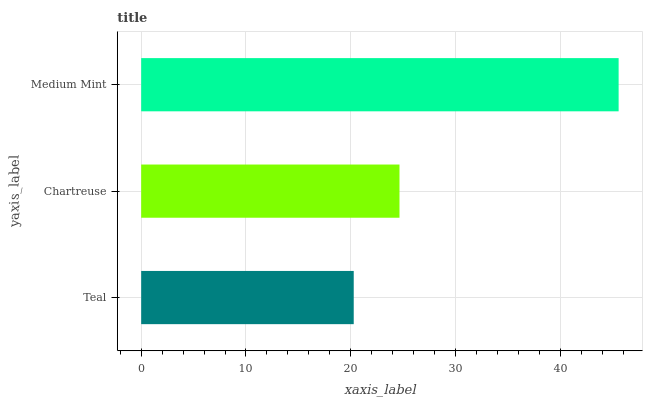Is Teal the minimum?
Answer yes or no. Yes. Is Medium Mint the maximum?
Answer yes or no. Yes. Is Chartreuse the minimum?
Answer yes or no. No. Is Chartreuse the maximum?
Answer yes or no. No. Is Chartreuse greater than Teal?
Answer yes or no. Yes. Is Teal less than Chartreuse?
Answer yes or no. Yes. Is Teal greater than Chartreuse?
Answer yes or no. No. Is Chartreuse less than Teal?
Answer yes or no. No. Is Chartreuse the high median?
Answer yes or no. Yes. Is Chartreuse the low median?
Answer yes or no. Yes. Is Teal the high median?
Answer yes or no. No. Is Teal the low median?
Answer yes or no. No. 